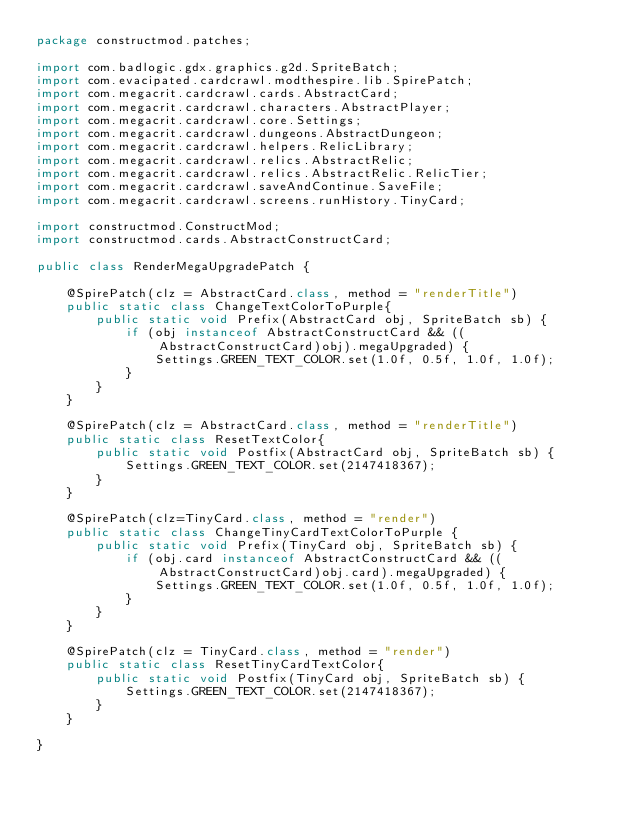Convert code to text. <code><loc_0><loc_0><loc_500><loc_500><_Java_>package constructmod.patches;

import com.badlogic.gdx.graphics.g2d.SpriteBatch;
import com.evacipated.cardcrawl.modthespire.lib.SpirePatch;
import com.megacrit.cardcrawl.cards.AbstractCard;
import com.megacrit.cardcrawl.characters.AbstractPlayer;
import com.megacrit.cardcrawl.core.Settings;
import com.megacrit.cardcrawl.dungeons.AbstractDungeon;
import com.megacrit.cardcrawl.helpers.RelicLibrary;
import com.megacrit.cardcrawl.relics.AbstractRelic;
import com.megacrit.cardcrawl.relics.AbstractRelic.RelicTier;
import com.megacrit.cardcrawl.saveAndContinue.SaveFile;
import com.megacrit.cardcrawl.screens.runHistory.TinyCard;

import constructmod.ConstructMod;
import constructmod.cards.AbstractConstructCard;

public class RenderMegaUpgradePatch {
	
	@SpirePatch(clz = AbstractCard.class, method = "renderTitle")
	public static class ChangeTextColorToPurple{
		public static void Prefix(AbstractCard obj, SpriteBatch sb) {
			if (obj instanceof AbstractConstructCard && ((AbstractConstructCard)obj).megaUpgraded) {
				Settings.GREEN_TEXT_COLOR.set(1.0f, 0.5f, 1.0f, 1.0f);
			}
		}
	}
	
	@SpirePatch(clz = AbstractCard.class, method = "renderTitle")
	public static class ResetTextColor{
		public static void Postfix(AbstractCard obj, SpriteBatch sb) {
			Settings.GREEN_TEXT_COLOR.set(2147418367);
		}
	}
	
	@SpirePatch(clz=TinyCard.class, method = "render")
	public static class ChangeTinyCardTextColorToPurple {
		public static void Prefix(TinyCard obj, SpriteBatch sb) {
			if (obj.card instanceof AbstractConstructCard && ((AbstractConstructCard)obj.card).megaUpgraded) {
				Settings.GREEN_TEXT_COLOR.set(1.0f, 0.5f, 1.0f, 1.0f);
			}
		}
	}
	
	@SpirePatch(clz = TinyCard.class, method = "render")
	public static class ResetTinyCardTextColor{
		public static void Postfix(TinyCard obj, SpriteBatch sb) {
			Settings.GREEN_TEXT_COLOR.set(2147418367);
		}
	}
	
}</code> 